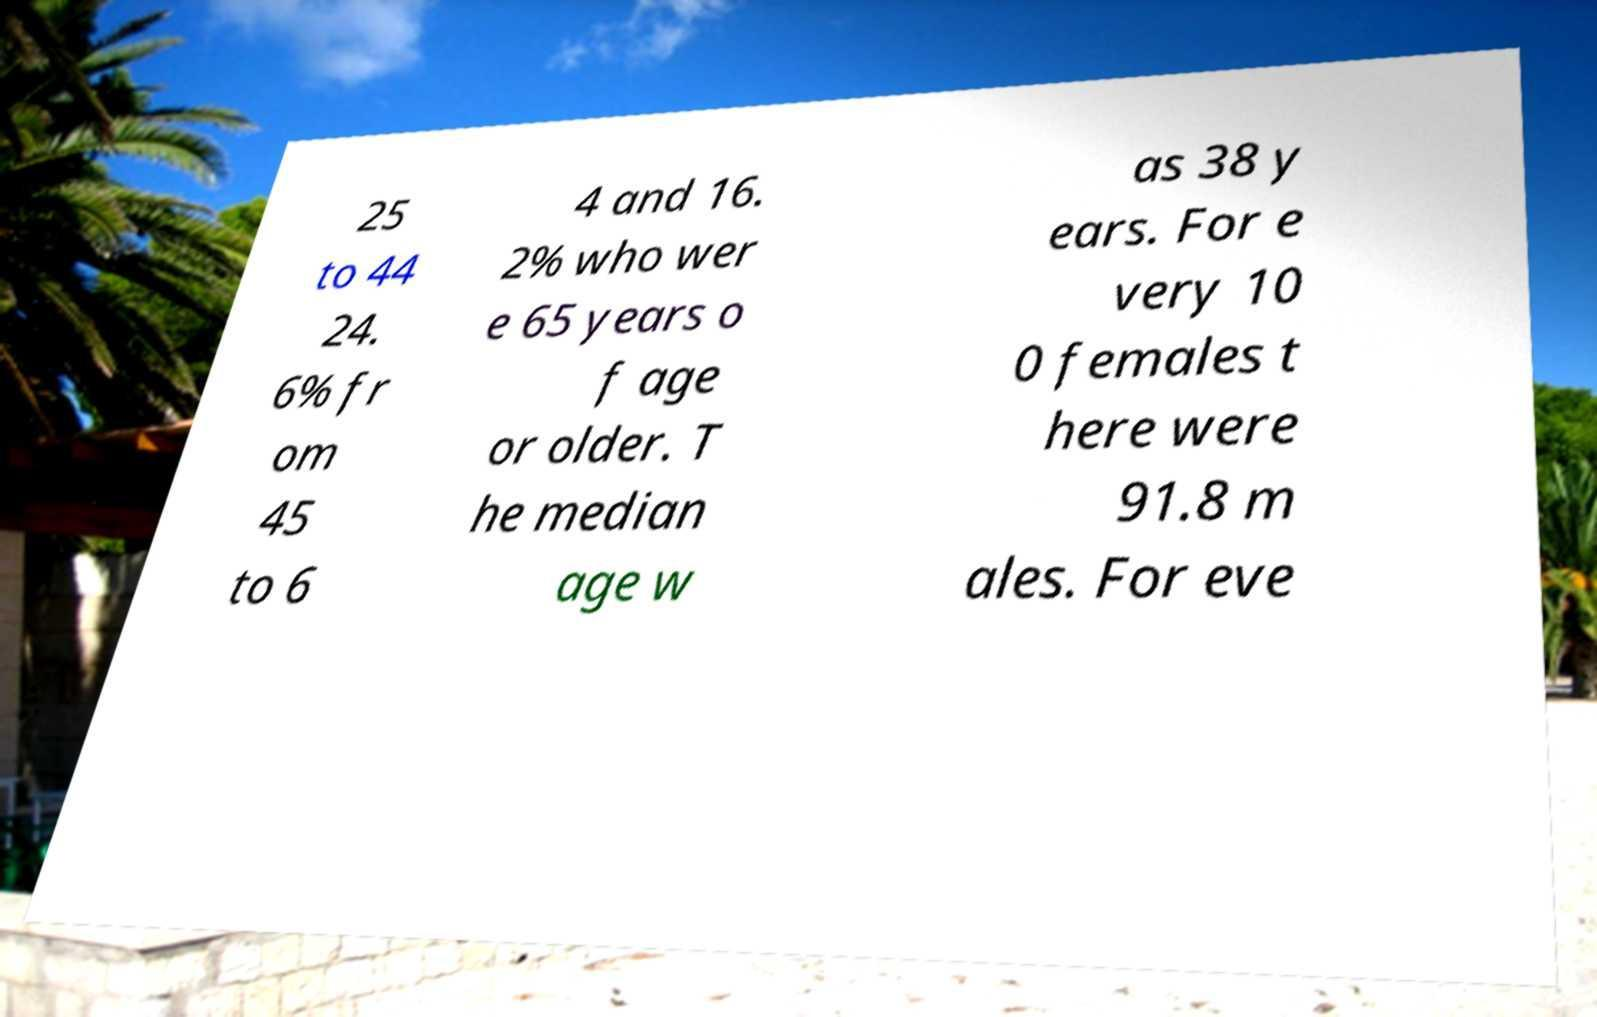I need the written content from this picture converted into text. Can you do that? 25 to 44 24. 6% fr om 45 to 6 4 and 16. 2% who wer e 65 years o f age or older. T he median age w as 38 y ears. For e very 10 0 females t here were 91.8 m ales. For eve 